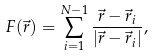Convert formula to latex. <formula><loc_0><loc_0><loc_500><loc_500>F ( \vec { r } ) = \sum _ { i = 1 } ^ { N - 1 } \frac { \vec { r } - \vec { r } _ { i } } { | \vec { r } - \vec { r } _ { i } | } ,</formula> 